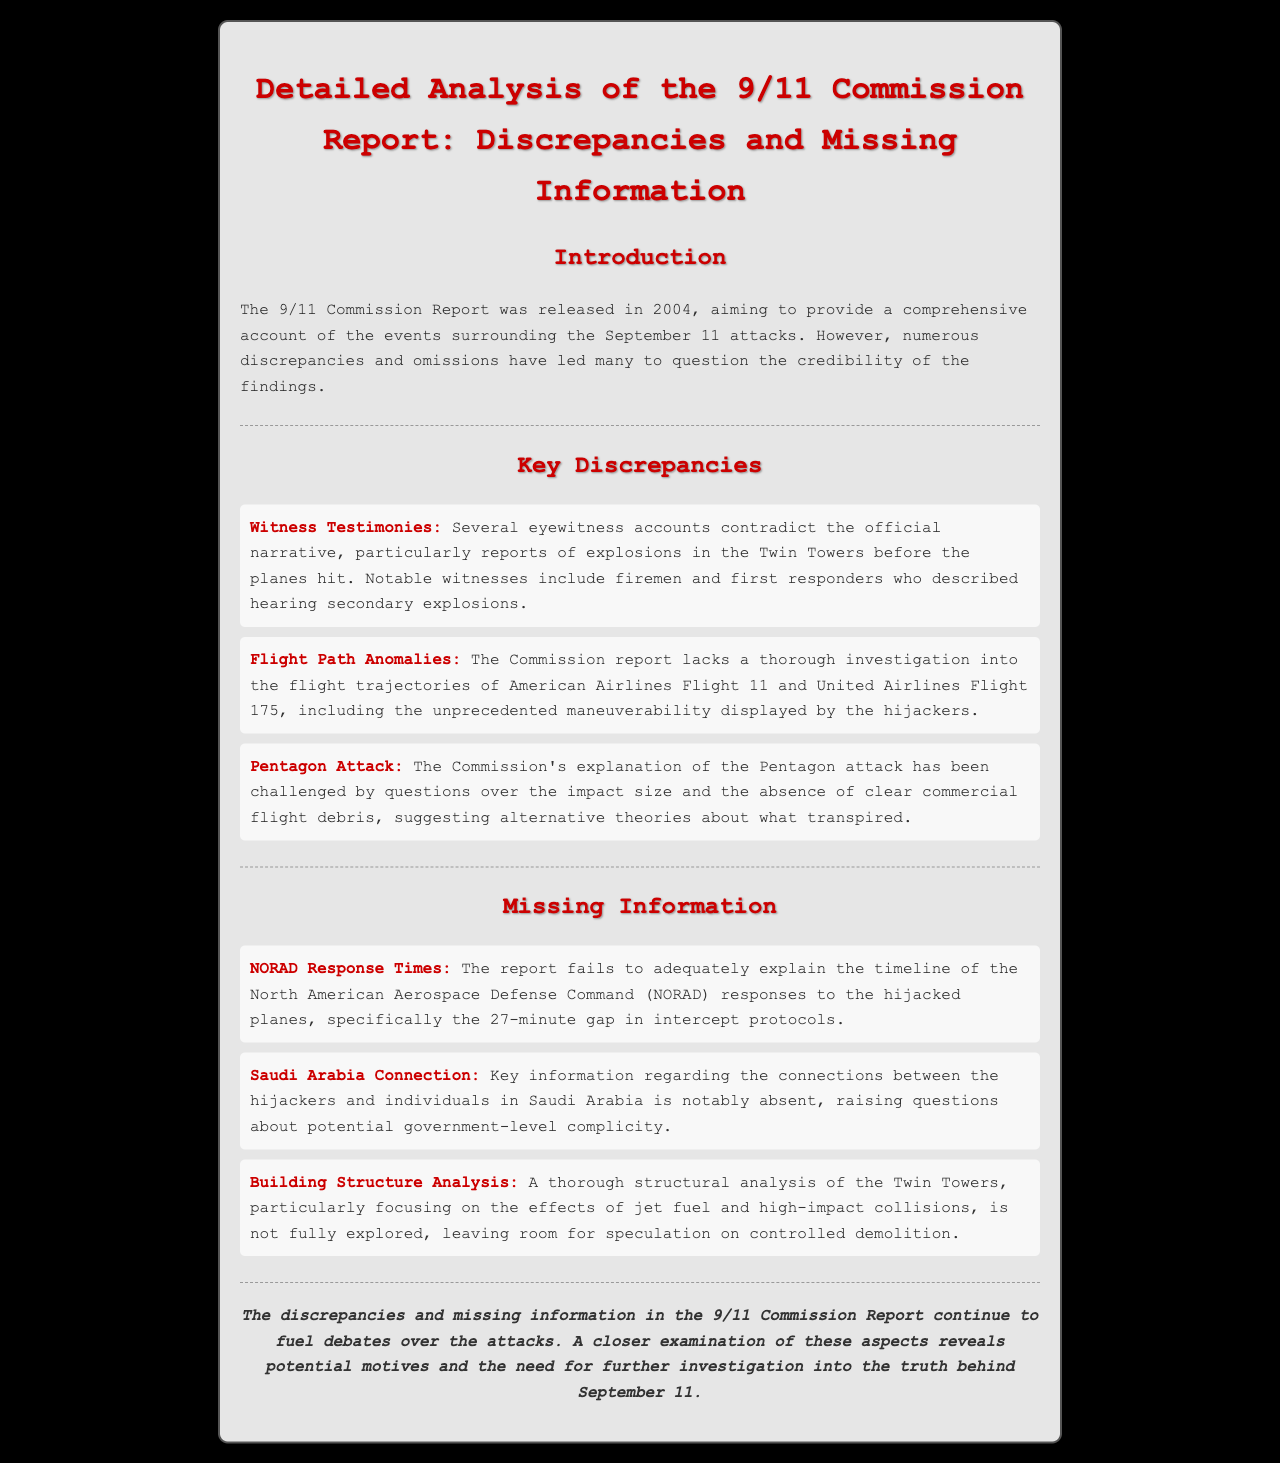what year was the 9/11 Commission Report released? The document states that the 9/11 Commission Report was released in 2004.
Answer: 2004 who described hearing secondary explosions? The document mentions firemen and first responders as witnesses who reported hearing secondary explosions.
Answer: firemen and first responders what significant gap is noted in NORAD's response? The report highlights a 27-minute gap in intercept protocols concerning NORAD's response.
Answer: 27-minute gap which two flights' maneuvers are questioned in the report? The document refers to the maneuvers of American Airlines Flight 11 and United Airlines Flight 175.
Answer: American Airlines Flight 11 and United Airlines Flight 175 what connection is notably absent regarding the hijackers? The report indicates a lack of information concerning connections between the hijackers and individuals in Saudi Arabia.
Answer: Saudi Arabia connection what type of analysis is missing from the report regarding the Twin Towers? The document mentions the absence of a thorough structural analysis of the Twin Towers.
Answer: structural analysis what is suggested about the Pentagon attack explanation? The report suggests that the explanation of the Pentagon attack has been challenged regarding the impact size.
Answer: impact size which aspect of the witnesses' testimonies is highlighted as a discrepancy? The document highlights that several eyewitness accounts contradict the official narrative, especially regarding explosions.
Answer: explosions 